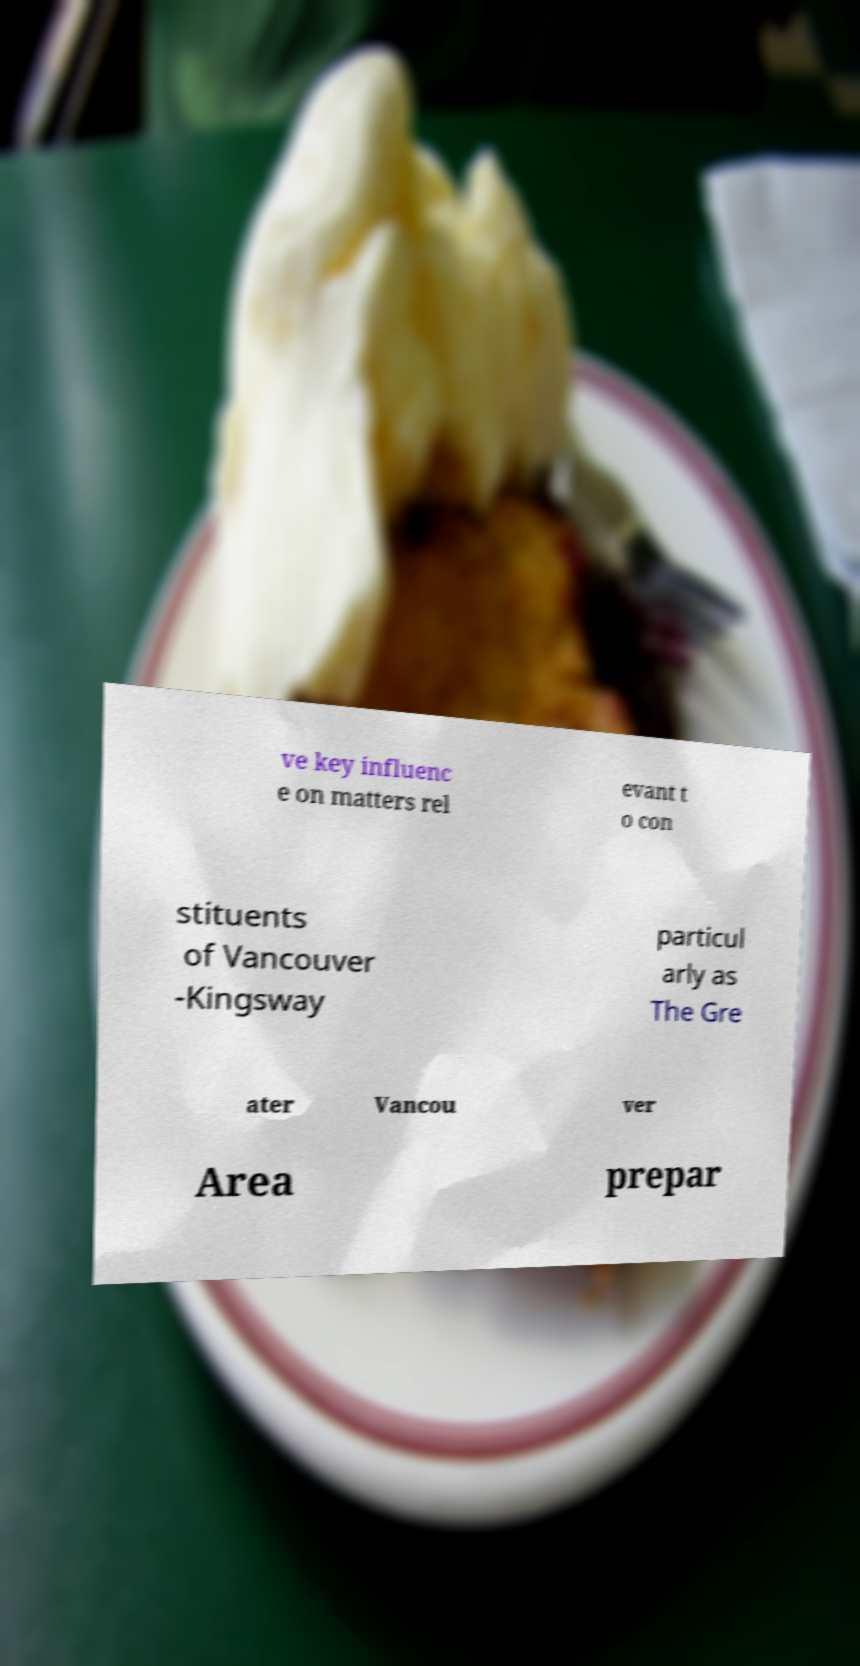Could you assist in decoding the text presented in this image and type it out clearly? ve key influenc e on matters rel evant t o con stituents of Vancouver -Kingsway particul arly as The Gre ater Vancou ver Area prepar 